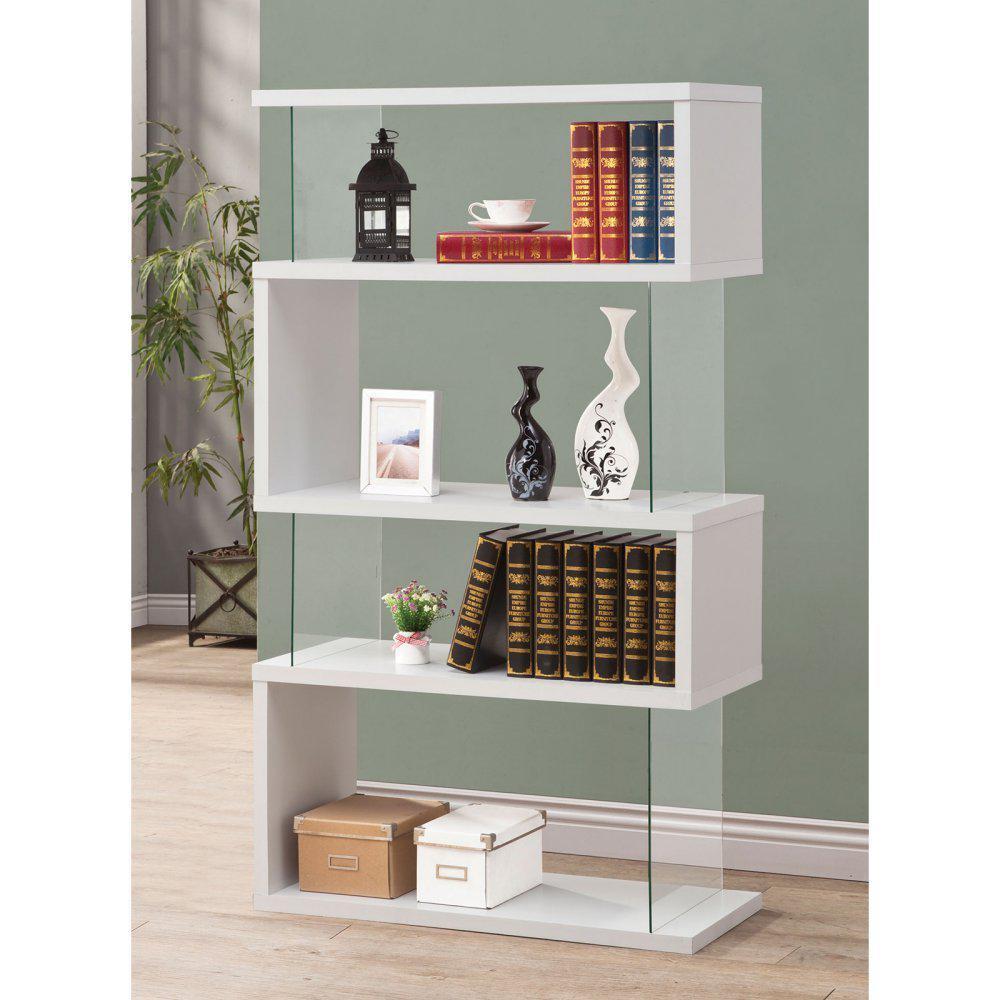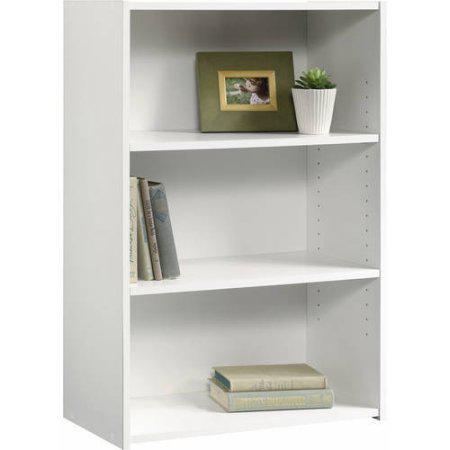The first image is the image on the left, the second image is the image on the right. Given the left and right images, does the statement "One of the bookshelves is not white." hold true? Answer yes or no. No. The first image is the image on the left, the second image is the image on the right. Assess this claim about the two images: "All shelf units shown are white, and all shelf units contain some books on some shelves.". Correct or not? Answer yes or no. Yes. 